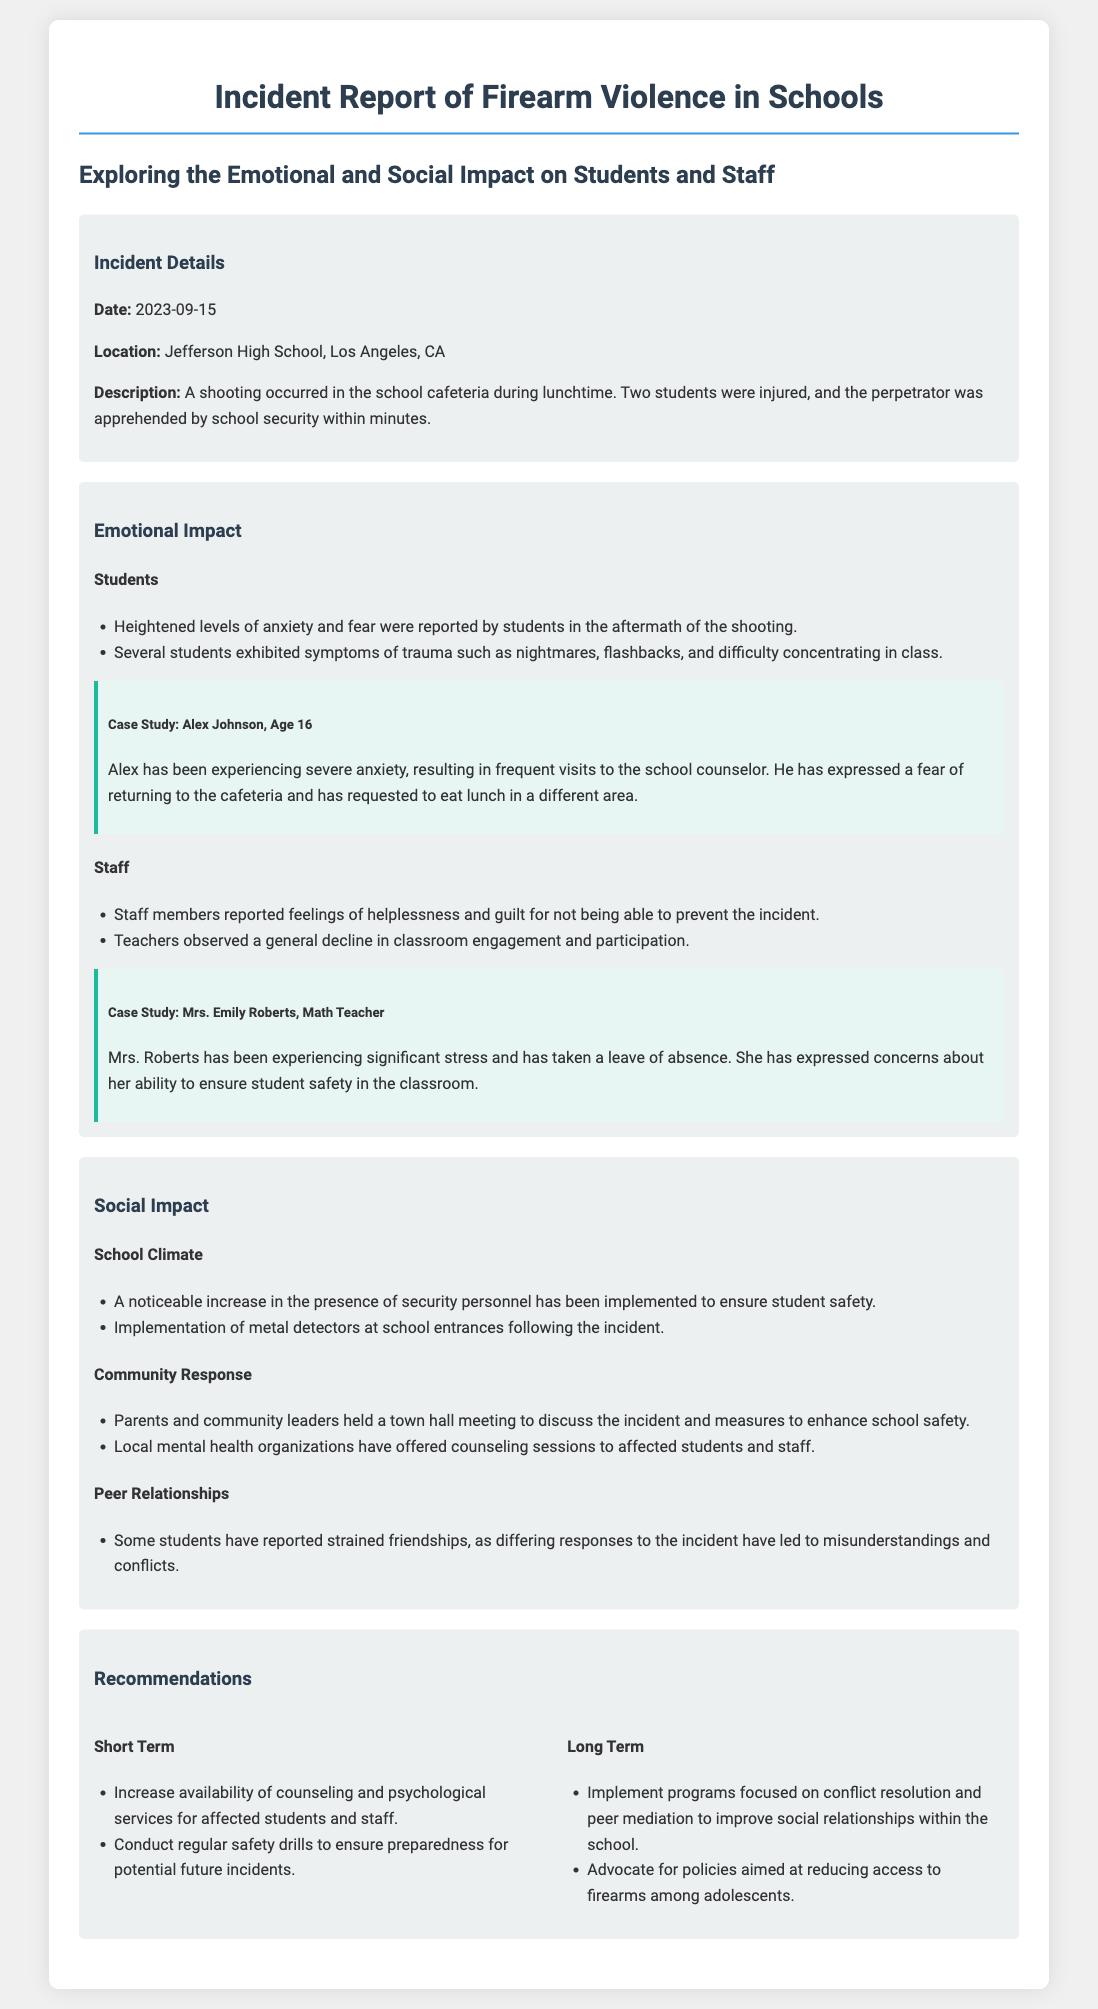What date did the incident occur? The incident report specifies that the date of the incident is mentioned in the document.
Answer: 2023-09-15 Where did the shooting take place? The report includes the location of the incident as part of the incident details section.
Answer: Jefferson High School, Los Angeles, CA How many students were injured? The document provides a specific count of students injured in the aftermath of the incident.
Answer: Two students What symptoms did students exhibit? The emotional impact section lists specific trauma symptoms reported by students after the incident.
Answer: Nightmares, flashbacks, difficulty concentrating What was the emotional response of staff members? Staff emotional impacts are summarized, detailing the feelings expressed in the report.
Answer: Helplessness and guilt What immediate action was taken for school safety? The report highlights changes made to enhance security in the aftermath of the incident as part of the social impact section.
Answer: Increase in the presence of security personnel What recommendation was made for long-term improvement? The recommendations section outlines specific long-term strategies aimed at enhancing safety and relationships in the school.
Answer: Implement programs focused on conflict resolution How did the community respond to the incident? The report discusses community actions taken following the incident, which is categorized within the social impact section.
Answer: Held a town hall meeting What case study is highlighted in the report? The document includes specific case studies to illustrate the individual emotional impacts experienced by students and staff.
Answer: Alex Johnson, Age 16 